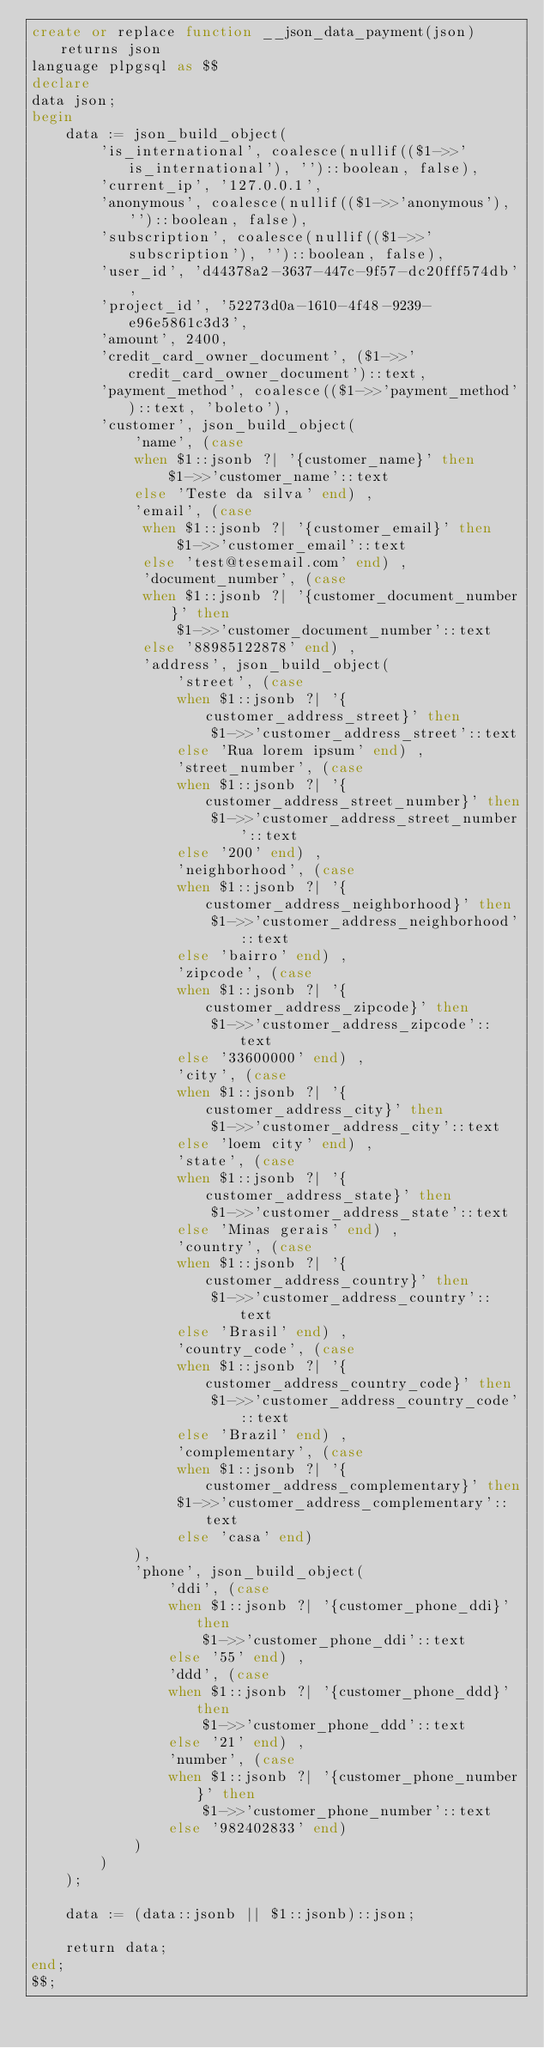<code> <loc_0><loc_0><loc_500><loc_500><_SQL_>create or replace function __json_data_payment(json) returns json
language plpgsql as $$
declare
data json;
begin
    data := json_build_object(
        'is_international', coalesce(nullif(($1->>'is_international'), '')::boolean, false),
        'current_ip', '127.0.0.1',
        'anonymous', coalesce(nullif(($1->>'anonymous'), '')::boolean, false),
        'subscription', coalesce(nullif(($1->>'subscription'), '')::boolean, false),
        'user_id', 'd44378a2-3637-447c-9f57-dc20fff574db',
        'project_id', '52273d0a-1610-4f48-9239-e96e5861c3d3',
        'amount', 2400,
        'credit_card_owner_document', ($1->>'credit_card_owner_document')::text,
        'payment_method', coalesce(($1->>'payment_method')::text, 'boleto'),
        'customer', json_build_object(
            'name', (case
            when $1::jsonb ?| '{customer_name}' then
                $1->>'customer_name'::text
            else 'Teste da silva' end) ,
            'email', (case
             when $1::jsonb ?| '{customer_email}' then
                 $1->>'customer_email'::text
             else 'test@tesemail.com' end) ,
             'document_number', (case
             when $1::jsonb ?| '{customer_document_number}' then
                 $1->>'customer_document_number'::text
             else '88985122878' end) ,
             'address', json_build_object(
                 'street', (case
                 when $1::jsonb ?| '{customer_address_street}' then
                     $1->>'customer_address_street'::text
                 else 'Rua lorem ipsum' end) ,
                 'street_number', (case
                 when $1::jsonb ?| '{customer_address_street_number}' then
                     $1->>'customer_address_street_number'::text
                 else '200' end) ,
                 'neighborhood', (case
                 when $1::jsonb ?| '{customer_address_neighborhood}' then
                     $1->>'customer_address_neighborhood'::text
                 else 'bairro' end) ,
                 'zipcode', (case
                 when $1::jsonb ?| '{customer_address_zipcode}' then
                     $1->>'customer_address_zipcode'::text
                 else '33600000' end) ,
                 'city', (case
                 when $1::jsonb ?| '{customer_address_city}' then
                     $1->>'customer_address_city'::text
                 else 'loem city' end) ,
                 'state', (case
                 when $1::jsonb ?| '{customer_address_state}' then
                     $1->>'customer_address_state'::text
                 else 'Minas gerais' end) ,
                 'country', (case
                 when $1::jsonb ?| '{customer_address_country}' then
                     $1->>'customer_address_country'::text
                 else 'Brasil' end) ,
                 'country_code', (case
                 when $1::jsonb ?| '{customer_address_country_code}' then
                     $1->>'customer_address_country_code'::text
                 else 'Brazil' end) ,
                 'complementary', (case
                 when $1::jsonb ?| '{customer_address_complementary}' then
                 $1->>'customer_address_complementary'::text
                 else 'casa' end)
            ),
            'phone', json_build_object(
                'ddi', (case
                when $1::jsonb ?| '{customer_phone_ddi}' then
                    $1->>'customer_phone_ddi'::text
                else '55' end) ,
                'ddd', (case
                when $1::jsonb ?| '{customer_phone_ddd}' then
                    $1->>'customer_phone_ddd'::text
                else '21' end) ,
                'number', (case
                when $1::jsonb ?| '{customer_phone_number}' then
                    $1->>'customer_phone_number'::text
                else '982402833' end)
            )
        )
    );

    data := (data::jsonb || $1::jsonb)::json;

    return data;
end;
$$;

</code> 